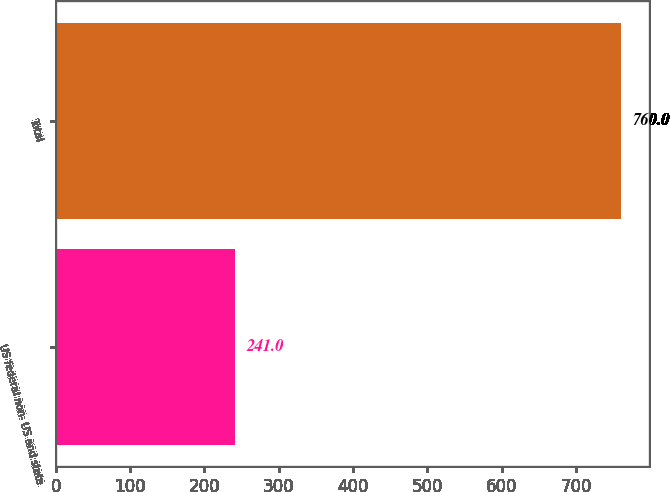Convert chart. <chart><loc_0><loc_0><loc_500><loc_500><bar_chart><fcel>US federal non- US and state<fcel>Total<nl><fcel>241<fcel>760<nl></chart> 